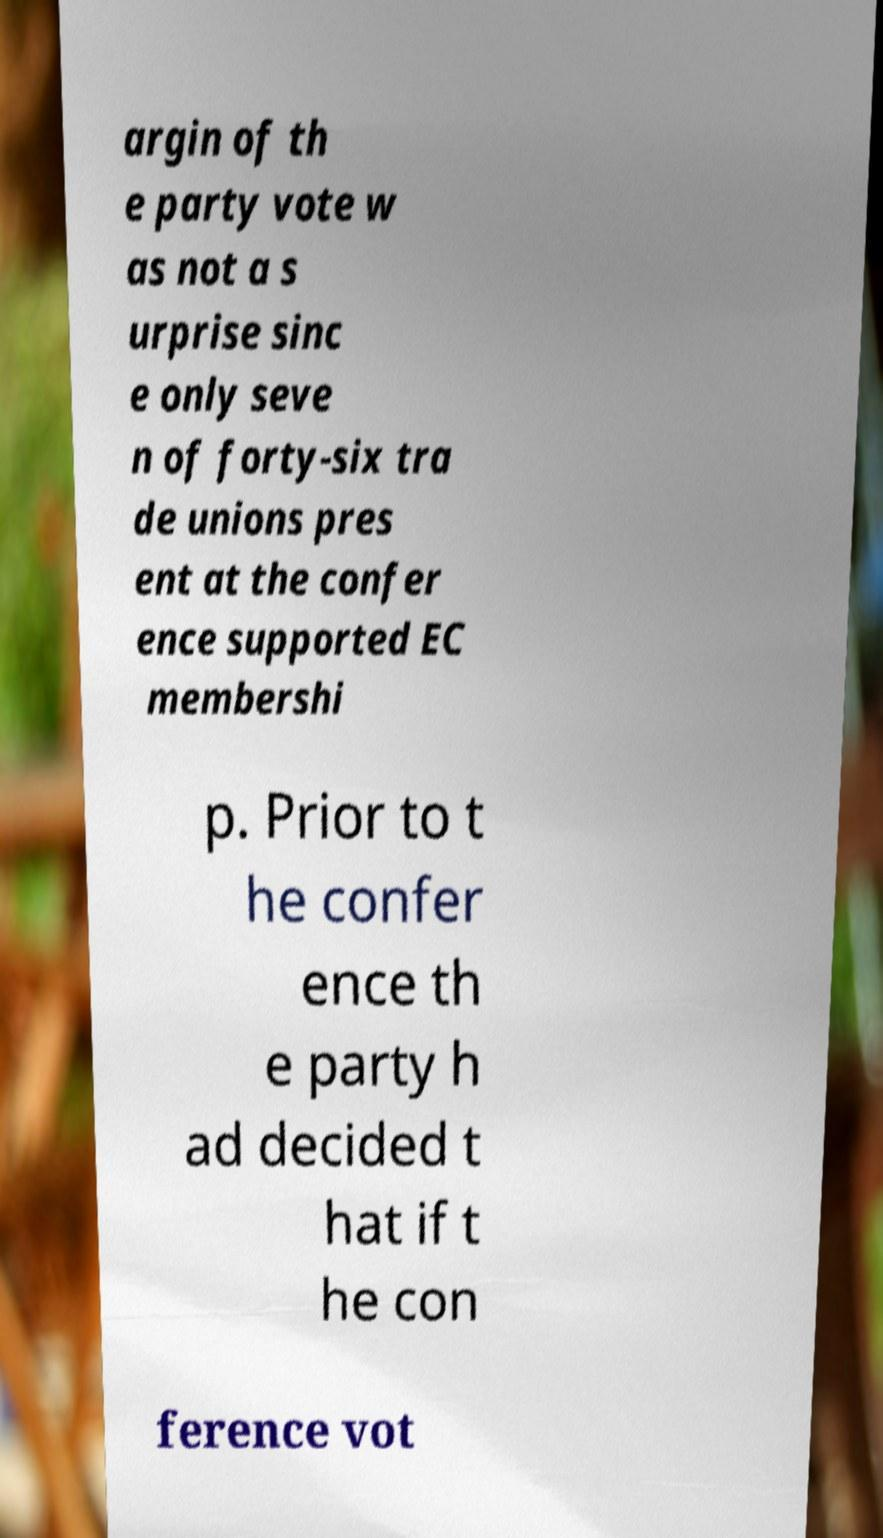There's text embedded in this image that I need extracted. Can you transcribe it verbatim? argin of th e party vote w as not a s urprise sinc e only seve n of forty-six tra de unions pres ent at the confer ence supported EC membershi p. Prior to t he confer ence th e party h ad decided t hat if t he con ference vot 